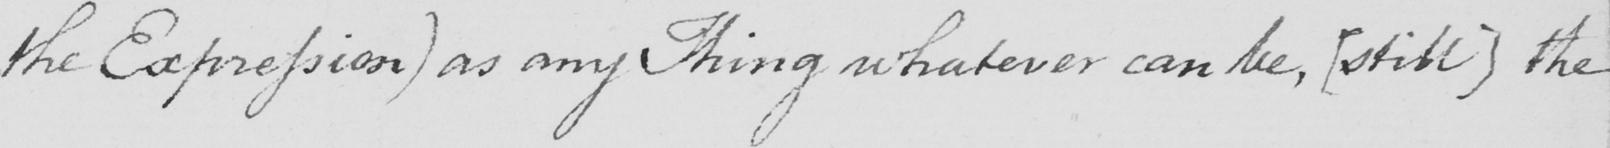Can you read and transcribe this handwriting? the Expression )  as any Thing whatever can be ,  [ still ]  the 